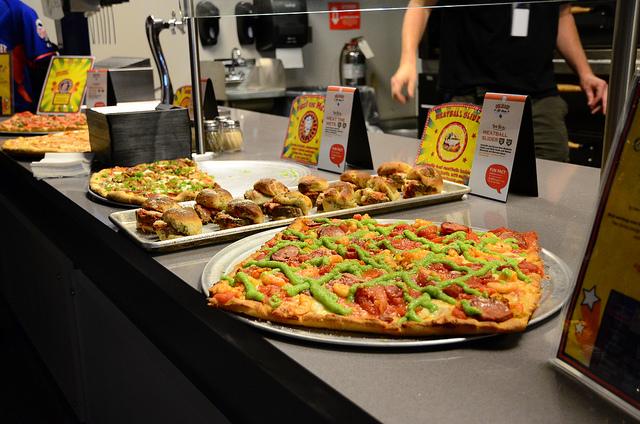Is that healthy?
Be succinct. No. Is the pizza whole?
Be succinct. Yes. What hand signal is this man giving?
Short answer required. None. Is anyone behind the counter?
Write a very short answer. Yes. Do you see a ham?
Quick response, please. No. Is the pizza outside?
Write a very short answer. No. Is this pizza homemade?
Give a very brief answer. No. Are the pizzas sitting on plates or in boxes?
Write a very short answer. Plates. How many pizzas?
Quick response, please. 4. What is the name of the tiny hamburgers?
Answer briefly. Sliders. What are the toothpicks used for in this picture?
Quick response, please. 0. What's on the pizza?
Keep it brief. Guacamole. Is that going to be delicious?
Short answer required. Yes. Where are the pizzas?
Answer briefly. Counter. What type of pork is on the pizza?
Write a very short answer. Pepperoni. 